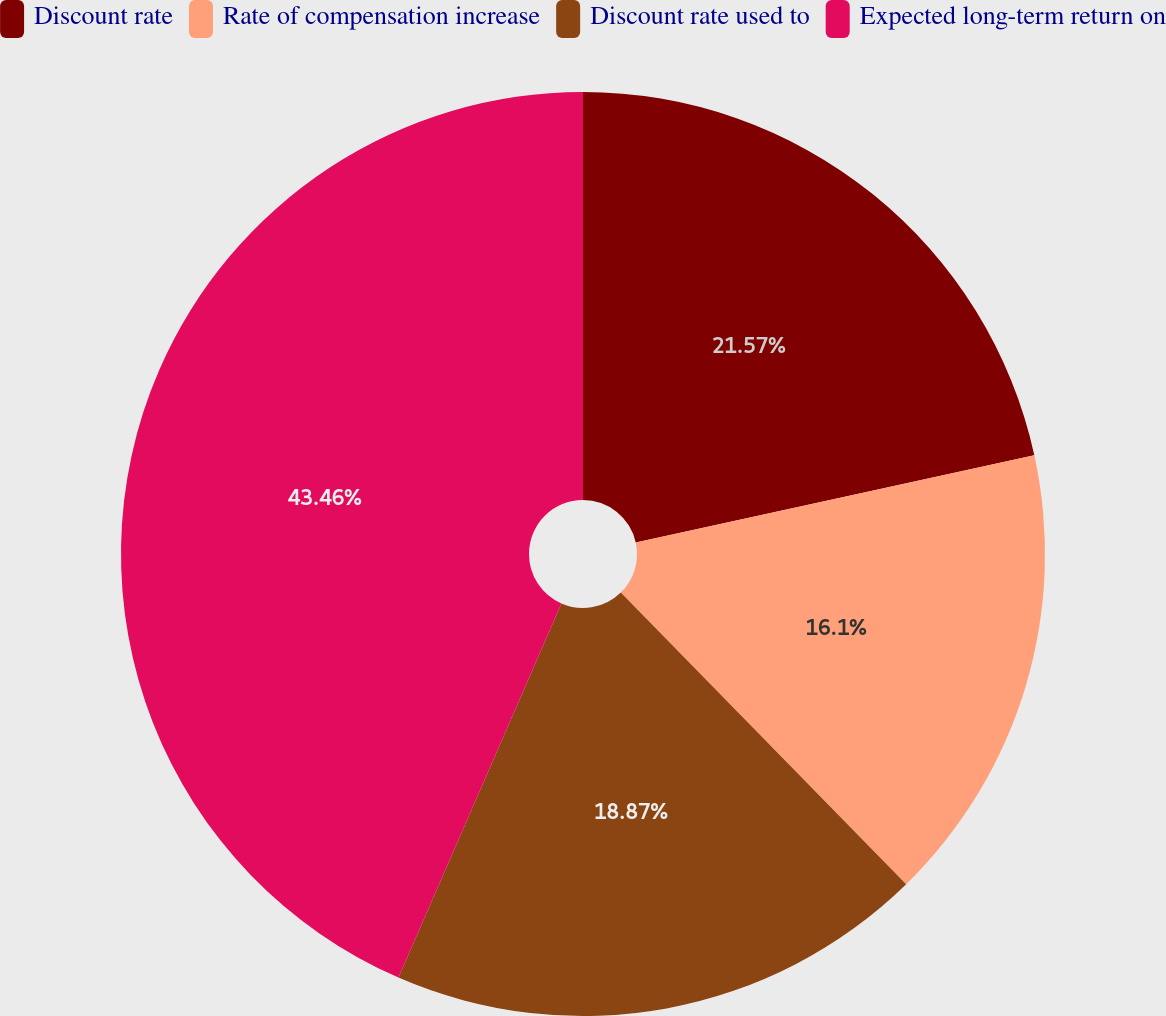Convert chart to OTSL. <chart><loc_0><loc_0><loc_500><loc_500><pie_chart><fcel>Discount rate<fcel>Rate of compensation increase<fcel>Discount rate used to<fcel>Expected long-term return on<nl><fcel>21.57%<fcel>16.1%<fcel>18.87%<fcel>43.46%<nl></chart> 